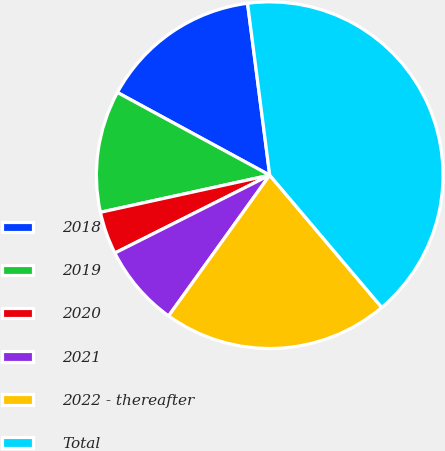Convert chart. <chart><loc_0><loc_0><loc_500><loc_500><pie_chart><fcel>2018<fcel>2019<fcel>2020<fcel>2021<fcel>2022 - thereafter<fcel>Total<nl><fcel>15.04%<fcel>11.35%<fcel>3.98%<fcel>7.67%<fcel>21.1%<fcel>40.86%<nl></chart> 